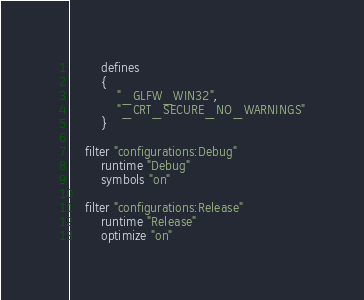<code> <loc_0><loc_0><loc_500><loc_500><_Lua_>
		defines 
		{ 
			"_GLFW_WIN32",
			"_CRT_SECURE_NO_WARNINGS"
		}

	filter "configurations:Debug"
		runtime "Debug"
		symbols "on"

	filter "configurations:Release"
		runtime "Release"
		optimize "on"
</code> 